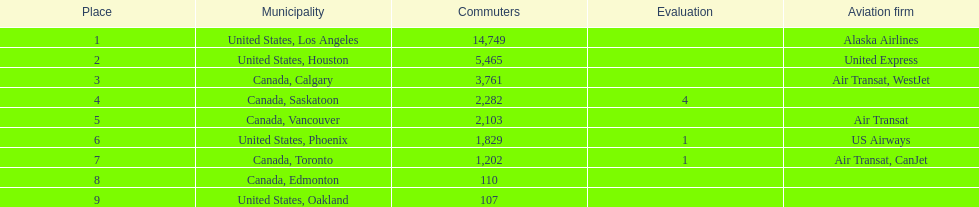Was los angeles or houston the busiest international route at manzanillo international airport in 2013? Los Angeles. 